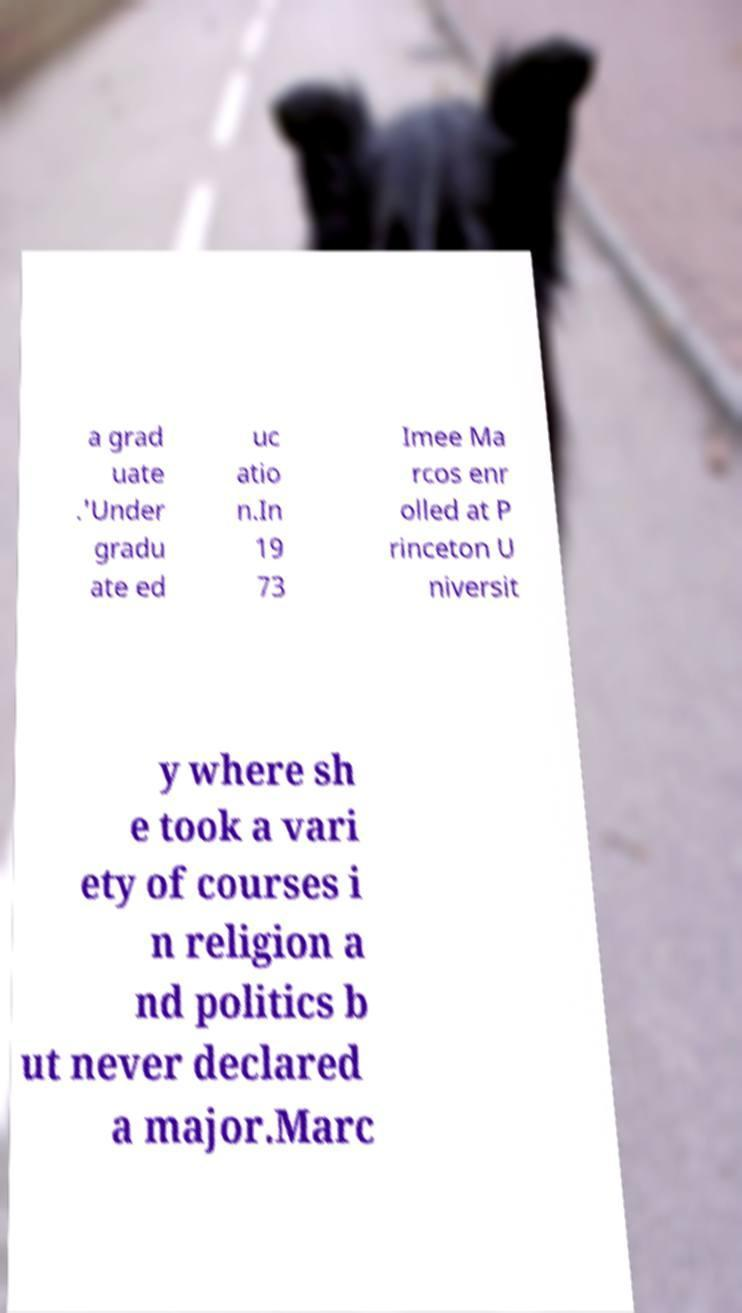Can you accurately transcribe the text from the provided image for me? a grad uate .'Under gradu ate ed uc atio n.In 19 73 Imee Ma rcos enr olled at P rinceton U niversit y where sh e took a vari ety of courses i n religion a nd politics b ut never declared a major.Marc 